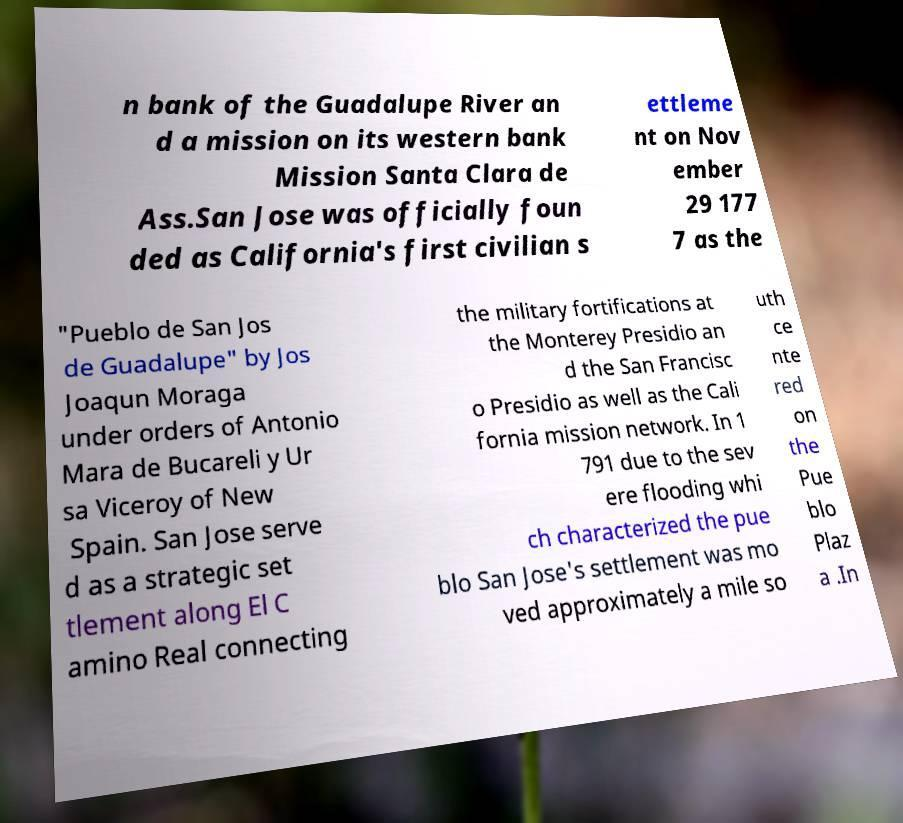Can you accurately transcribe the text from the provided image for me? n bank of the Guadalupe River an d a mission on its western bank Mission Santa Clara de Ass.San Jose was officially foun ded as California's first civilian s ettleme nt on Nov ember 29 177 7 as the "Pueblo de San Jos de Guadalupe" by Jos Joaqun Moraga under orders of Antonio Mara de Bucareli y Ur sa Viceroy of New Spain. San Jose serve d as a strategic set tlement along El C amino Real connecting the military fortifications at the Monterey Presidio an d the San Francisc o Presidio as well as the Cali fornia mission network. In 1 791 due to the sev ere flooding whi ch characterized the pue blo San Jose's settlement was mo ved approximately a mile so uth ce nte red on the Pue blo Plaz a .In 